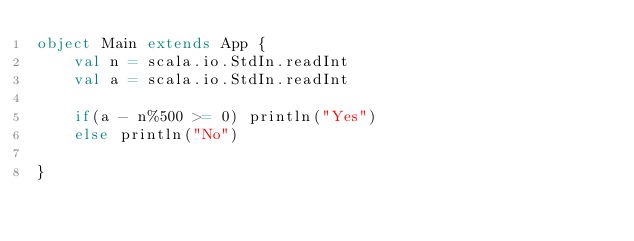Convert code to text. <code><loc_0><loc_0><loc_500><loc_500><_Scala_>object Main extends App {
	val n = scala.io.StdIn.readInt
	val a = scala.io.StdIn.readInt

	if(a - n%500 >= 0) println("Yes")
	else println("No")

}</code> 